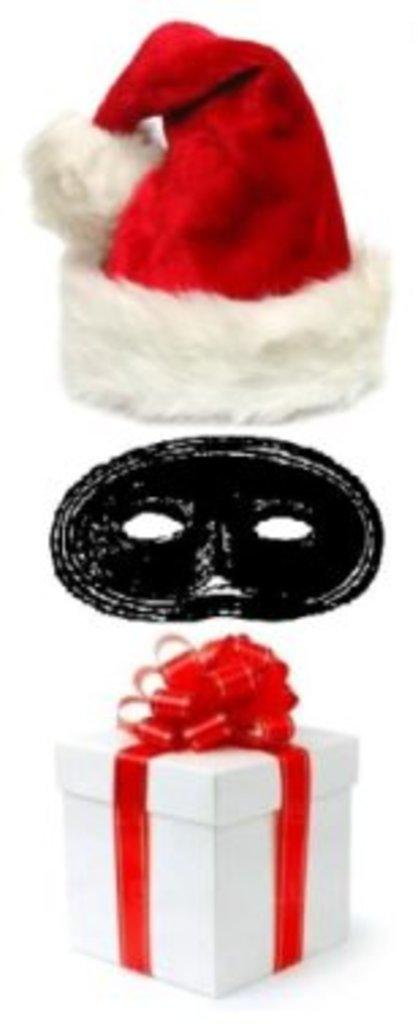What type of accessory is present in the image? There is a cap in the image. What other item can be seen in the image? There is a mask in the image. What might be a present for someone in the image? There is a gift box in the image. What color is the background of the image? The background of the image is white. What is the color of the surface in the image? The surface of the image has a white color. What type of yard can be seen in the image? There is no yard present in the image; it only contains a cap, a mask, a gift box, and a white background. 